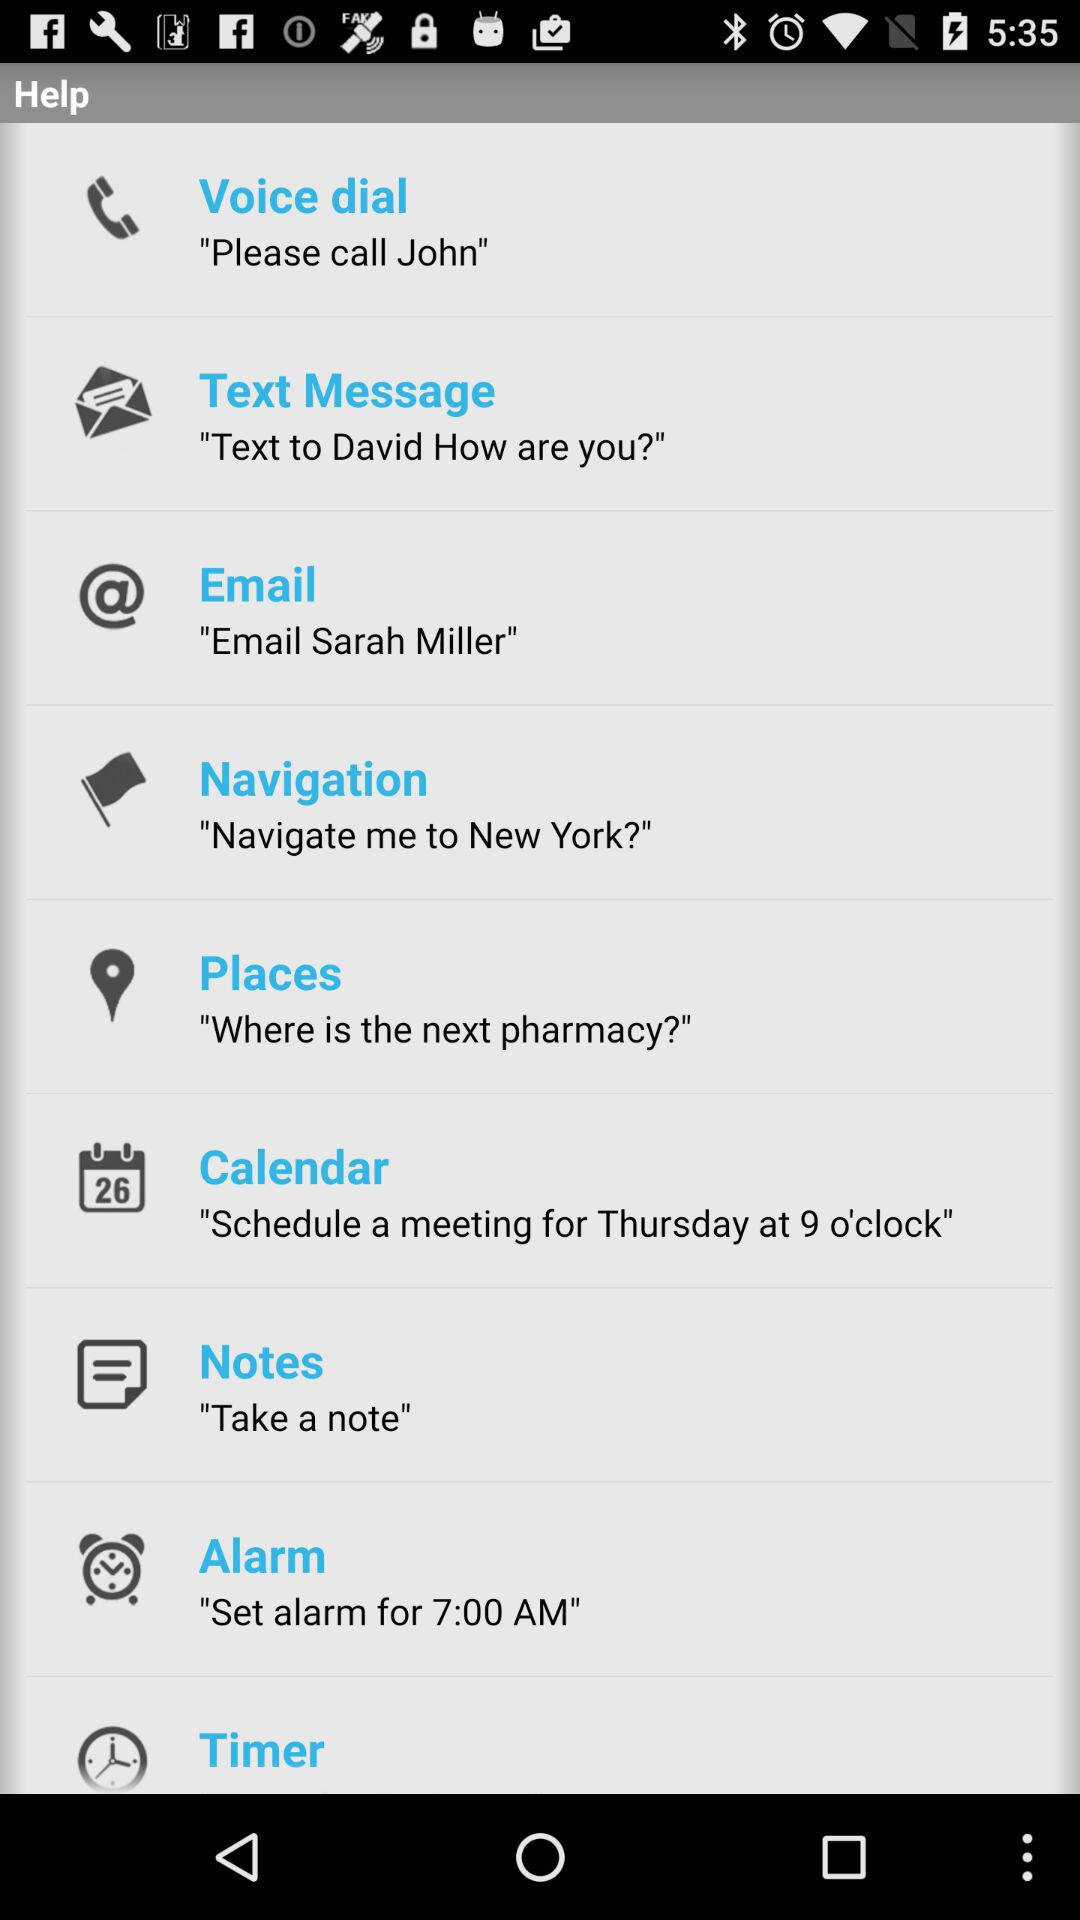What is the text message? The text message is "Text to David How are you?". 